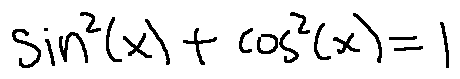Convert formula to latex. <formula><loc_0><loc_0><loc_500><loc_500>\sin ^ { 2 } ( x ) + \cos ^ { 2 } ( x ) = 1</formula> 